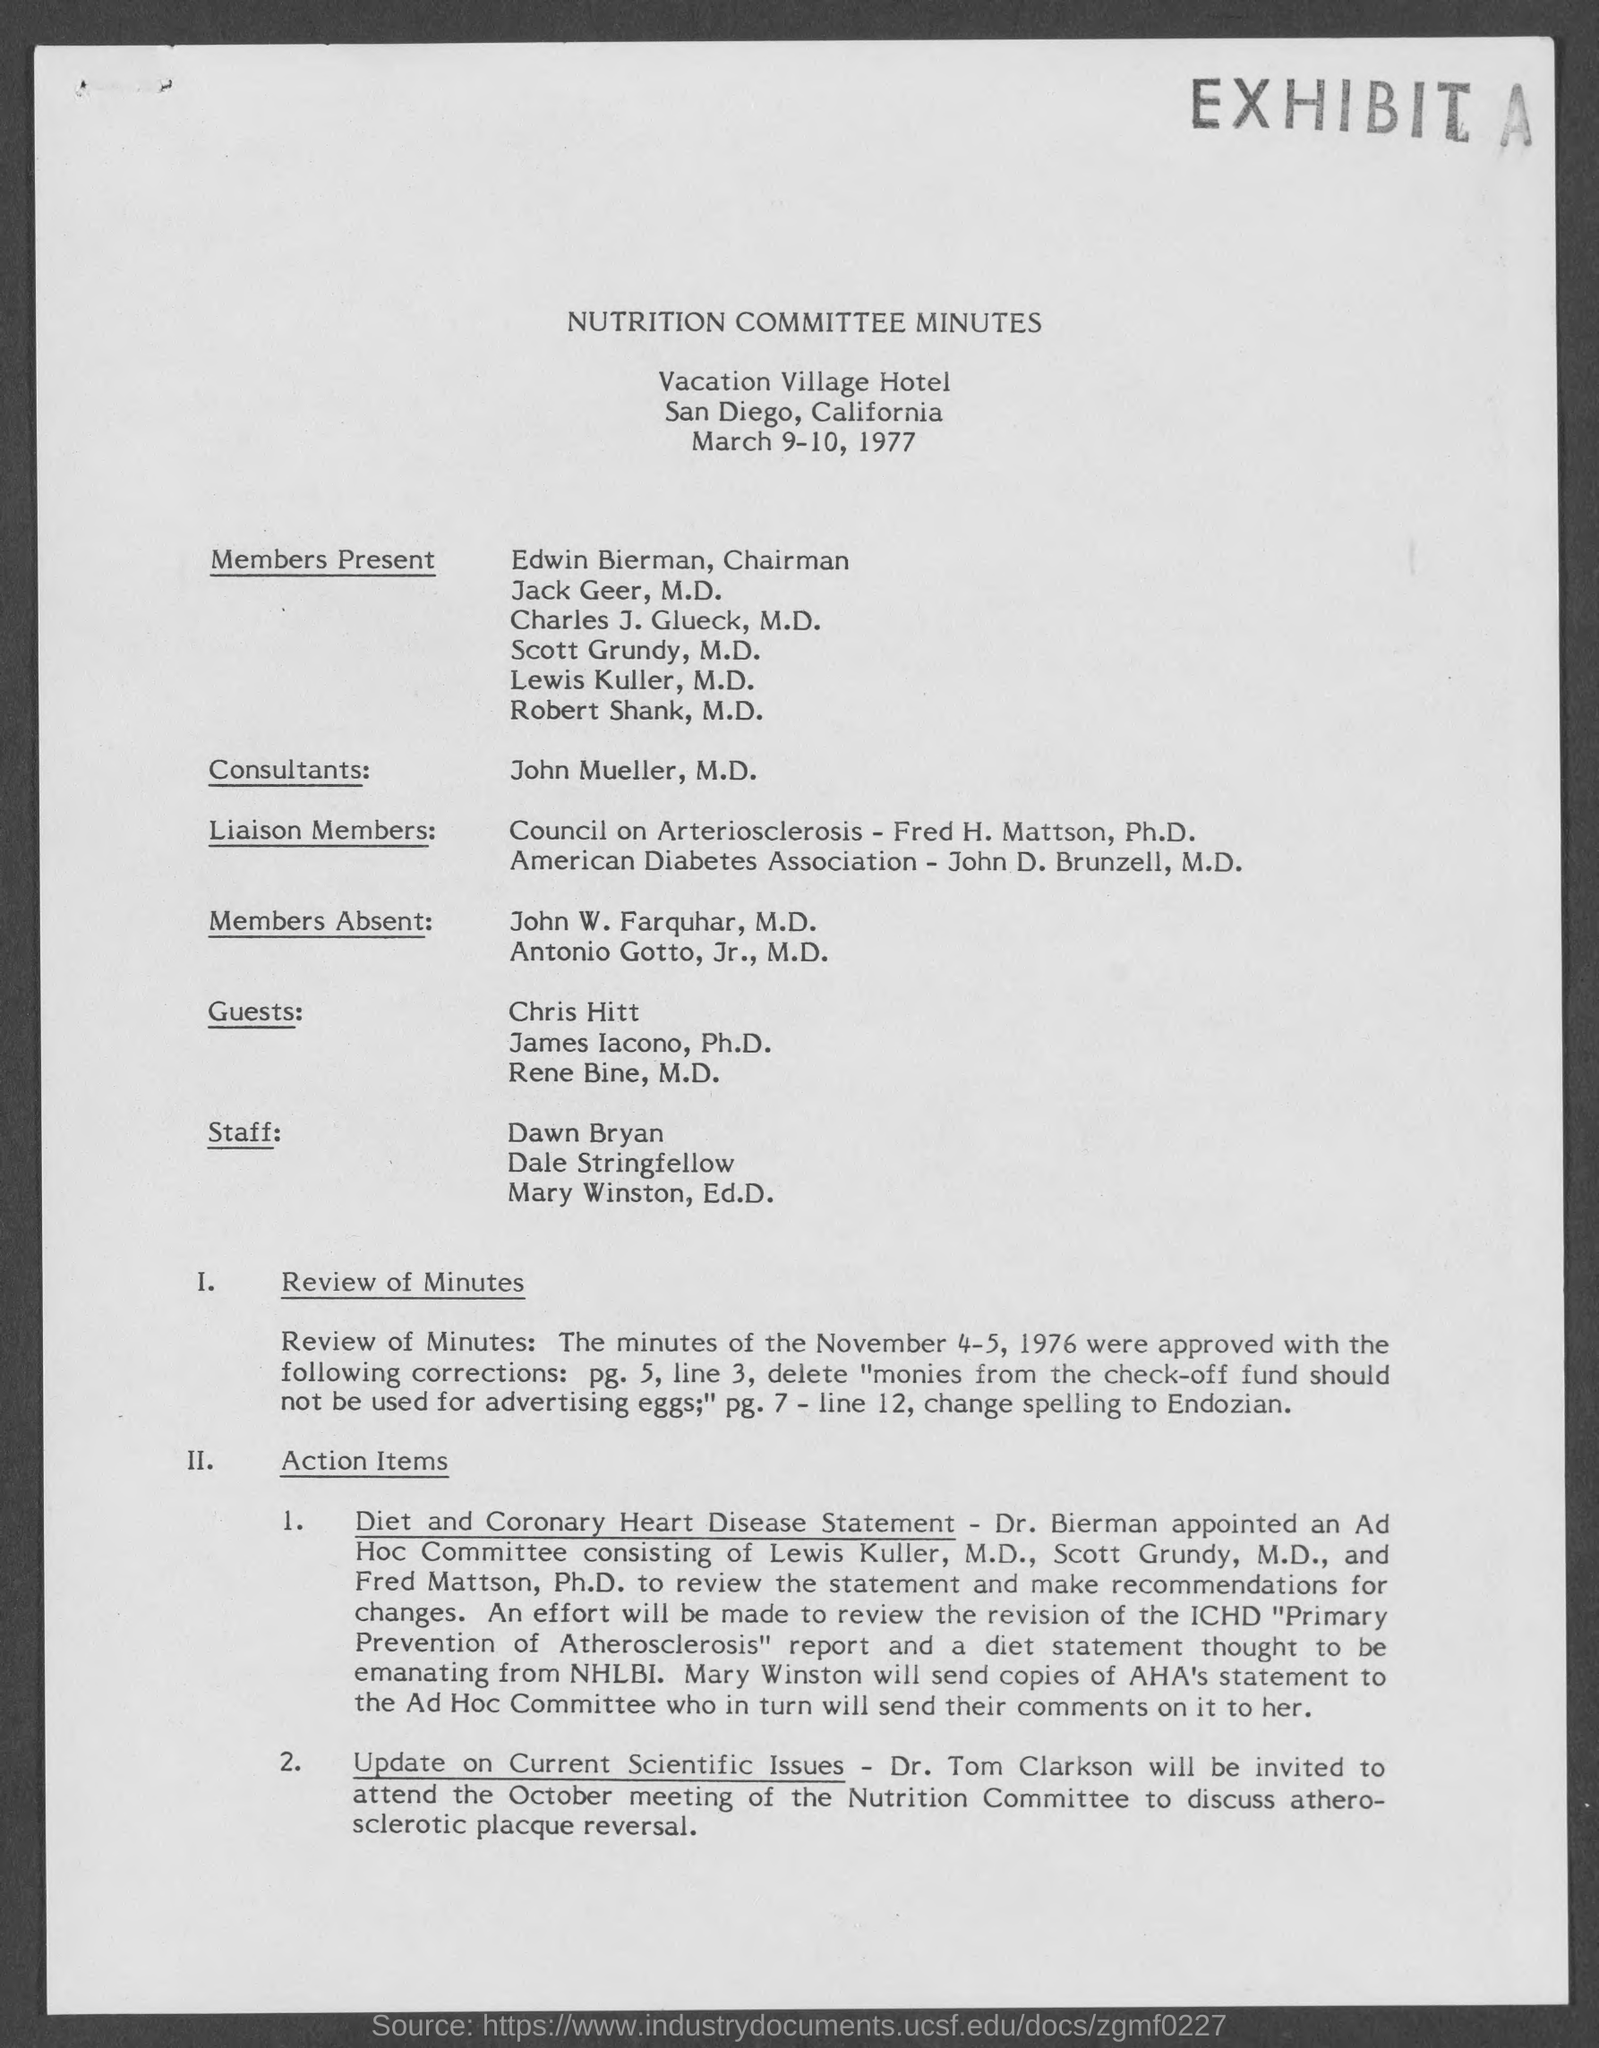Give some essential details in this illustration. On March 9 and 10, 1977, the date was. 